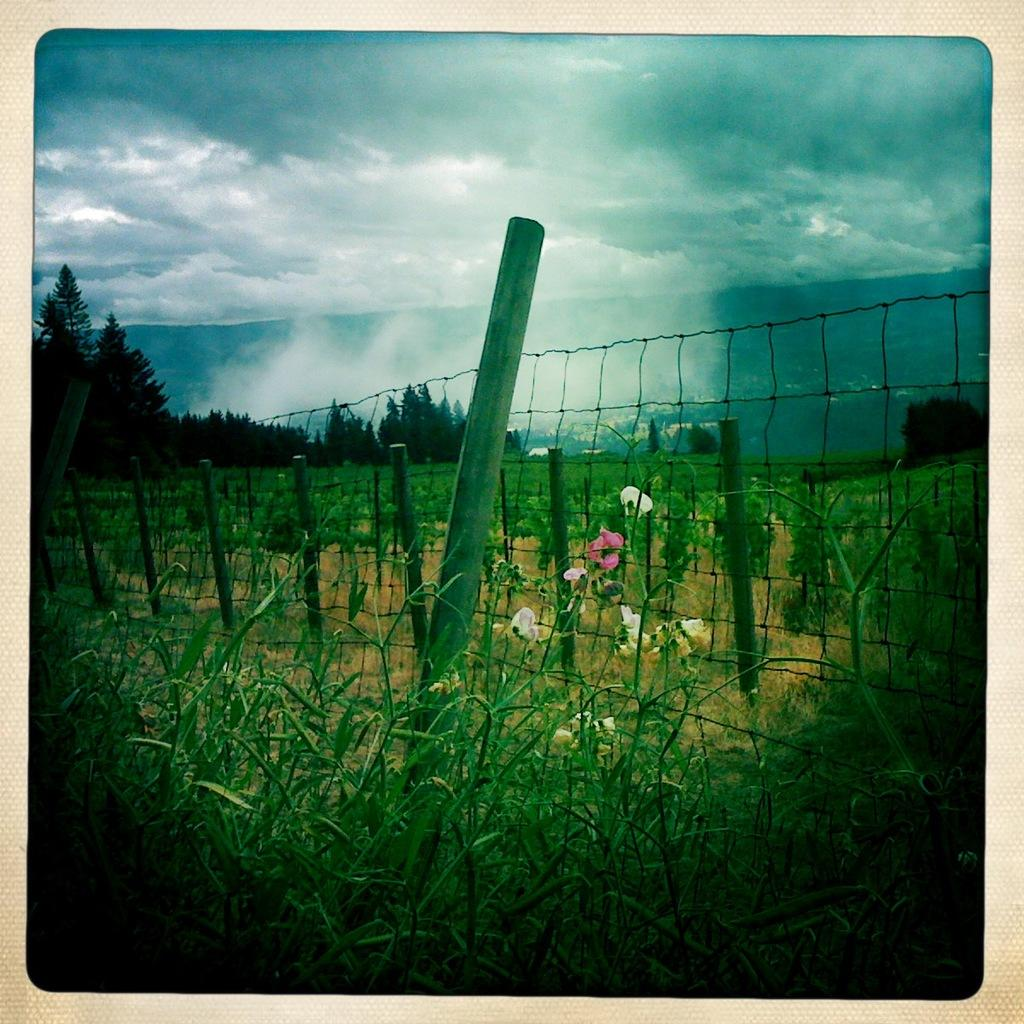What type of vegetation can be seen in the image? There are plants, flowers, and trees in the image. What structures are present in the image? There is a fence and poles in the image. What can be seen in the background of the image? There are trees and the sky visible in the background of the image. What is the condition of the sky in the image? The sky is visible with clouds in the background of the image. What direction is the uncle facing in the image? There is no uncle present in the image. What type of floor can be seen in the image? There is no floor visible in the image, as it appears to be an outdoor scene. 